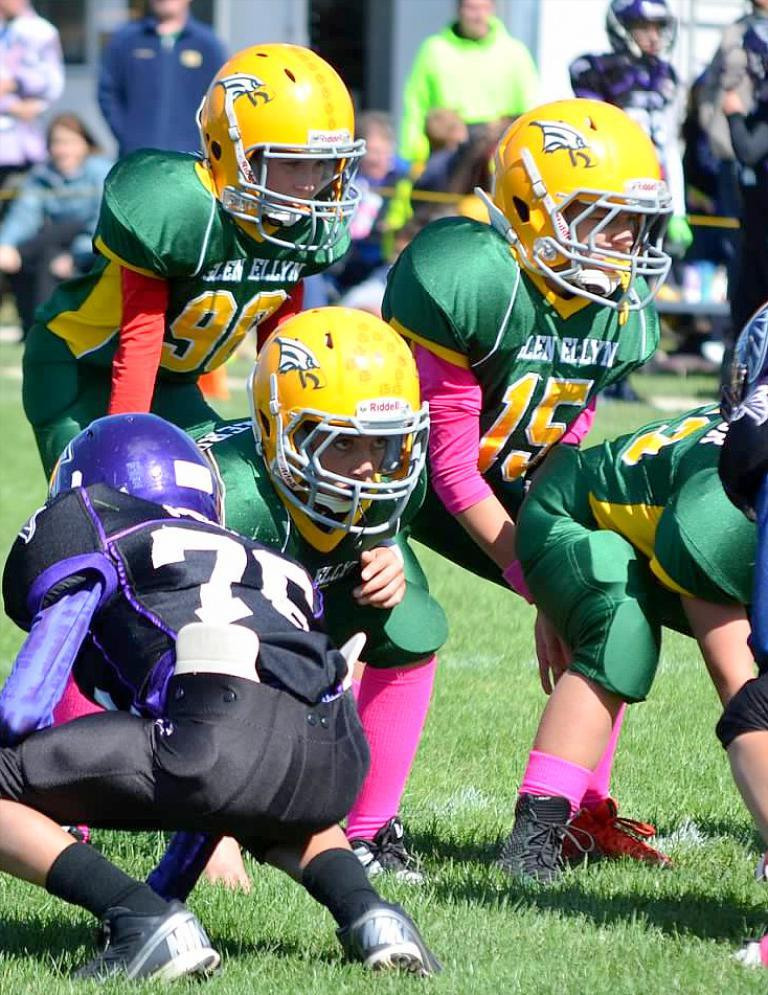What are the people in the image doing? The people in the image are playing. What are the people wearing on their heads? The people are wearing helmets. What type of footwear are the people wearing? The people are wearing shoes. What type of surface can be seen in the image? There is grass visible in the image. How would you describe the background of the image? The background of the image is blurred. Can you see any tigers playing with the people in the image? There are no tigers present in the image. How many books can be seen in the hands of the people playing in the image? There are no books visible in the image. 